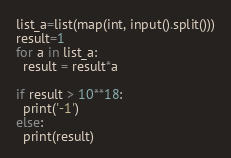Convert code to text. <code><loc_0><loc_0><loc_500><loc_500><_Python_>list_a=list(map(int, input().split()))
result=1
for a in list_a:
  result = result*a
  
if result > 10**18:
  print('-1')
else:
  print(result)</code> 